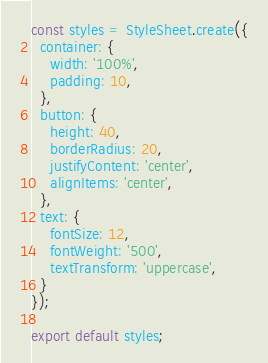Convert code to text. <code><loc_0><loc_0><loc_500><loc_500><_JavaScript_>
const styles = StyleSheet.create({
  container: {
    width: '100%',
    padding: 10,
  },
  button: {
    height: 40,
    borderRadius: 20,
    justifyContent: 'center',
    alignItems: 'center',
  },
  text: {
    fontSize: 12,
    fontWeight: '500',
    textTransform: 'uppercase',
  }
});

export default styles;
</code> 